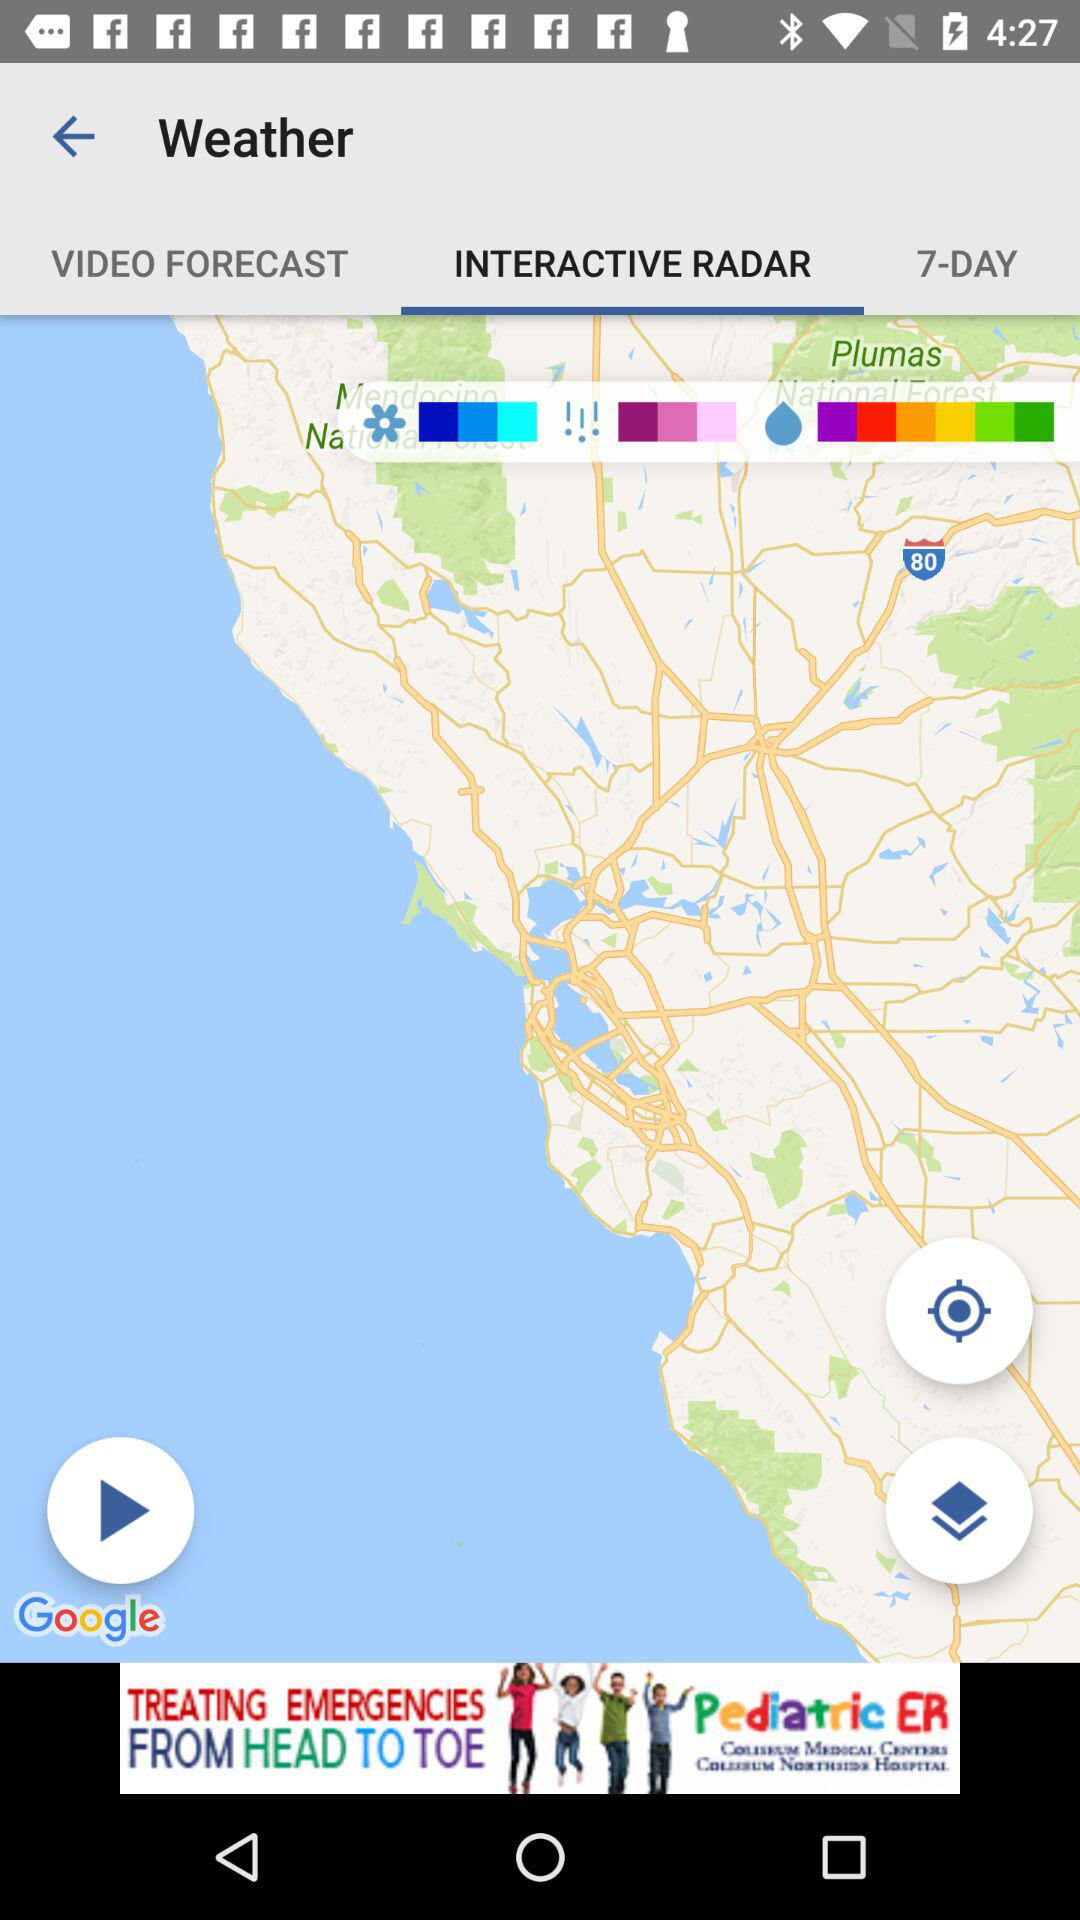What tab is selected? The selected tab is "INTERACTIVE RADAR". 